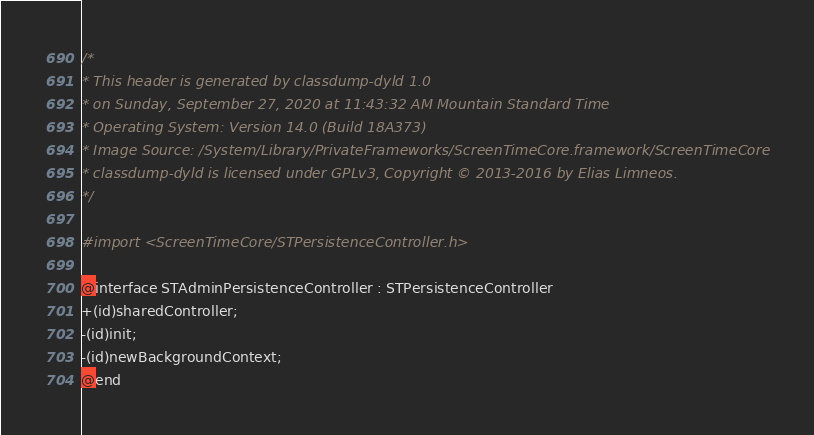<code> <loc_0><loc_0><loc_500><loc_500><_C_>/*
* This header is generated by classdump-dyld 1.0
* on Sunday, September 27, 2020 at 11:43:32 AM Mountain Standard Time
* Operating System: Version 14.0 (Build 18A373)
* Image Source: /System/Library/PrivateFrameworks/ScreenTimeCore.framework/ScreenTimeCore
* classdump-dyld is licensed under GPLv3, Copyright © 2013-2016 by Elias Limneos.
*/

#import <ScreenTimeCore/STPersistenceController.h>

@interface STAdminPersistenceController : STPersistenceController
+(id)sharedController;
-(id)init;
-(id)newBackgroundContext;
@end

</code> 